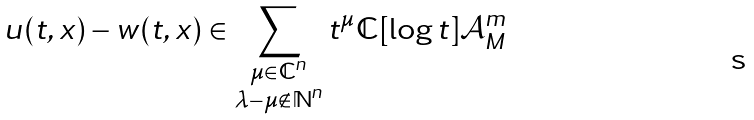Convert formula to latex. <formula><loc_0><loc_0><loc_500><loc_500>u ( t , x ) - w ( t , x ) \in \sum _ { \substack { \mu \in \mathbb { C } ^ { n } \\ \lambda - \mu \notin \mathbb { N } ^ { n } } } t ^ { \mu } \mathbb { C } [ \log t ] \mathcal { A } _ { M } ^ { m }</formula> 